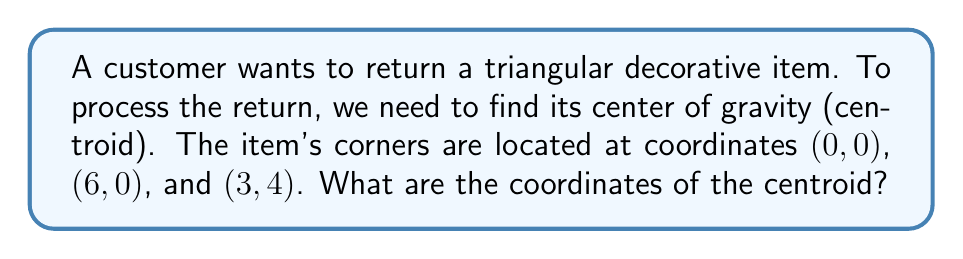What is the answer to this math problem? Let's approach this step-by-step:

1) The centroid of a triangle is located at the intersection of its medians. It can be calculated using the average of the x-coordinates and y-coordinates of the triangle's vertices.

2) The formula for the centroid (x, y) is:

   $$x = \frac{x_1 + x_2 + x_3}{3}$$
   $$y = \frac{y_1 + y_2 + y_3}{3}$$

   where $(x_1, y_1)$, $(x_2, y_2)$, and $(x_3, y_3)$ are the coordinates of the triangle's vertices.

3) We have the following vertices:
   - $A(0, 0)$
   - $B(6, 0)$
   - $C(3, 4)$

4) Let's calculate the x-coordinate of the centroid:

   $$x = \frac{0 + 6 + 3}{3} = \frac{9}{3} = 3$$

5) Now, let's calculate the y-coordinate of the centroid:

   $$y = \frac{0 + 0 + 4}{3} = \frac{4}{3} \approx 1.33$$

6) Therefore, the centroid is located at (3, 4/3).

[asy]
unitsize(1cm);
draw((0,0)--(6,0)--(3,4)--cycle);
dot((0,0));
dot((6,0));
dot((3,4));
dot((3,4/3), red);
label("A(0,0)", (0,0), SW);
label("B(6,0)", (6,0), SE);
label("C(3,4)", (3,4), N);
label("Centroid", (3,4/3), E);
[/asy]
Answer: (3, 4/3) 